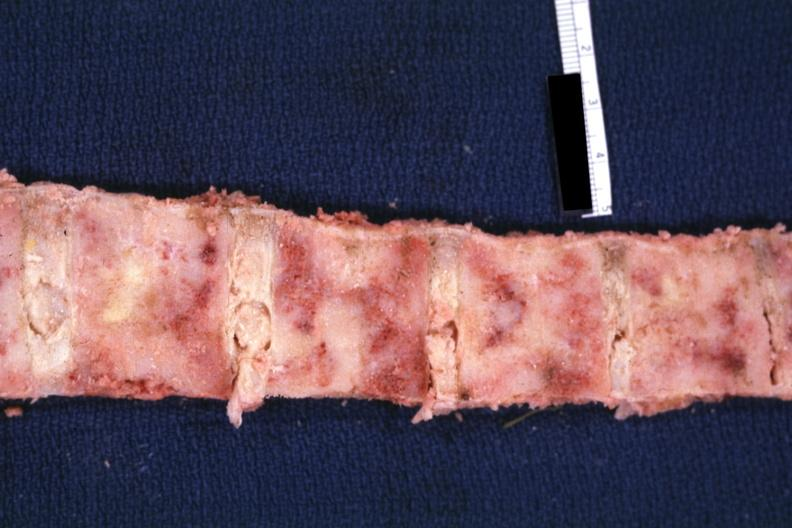what is bone nearly completely filled with tumor primary?
Answer the question using a single word or phrase. Lung 